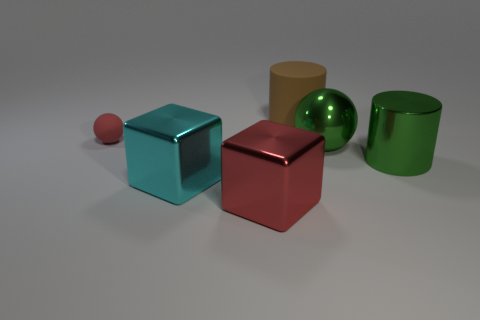Add 1 small green shiny balls. How many objects exist? 7 Subtract all balls. How many objects are left? 4 Subtract 0 purple cylinders. How many objects are left? 6 Subtract all rubber things. Subtract all tiny blue matte blocks. How many objects are left? 4 Add 2 red metal blocks. How many red metal blocks are left? 3 Add 4 green spheres. How many green spheres exist? 5 